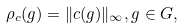Convert formula to latex. <formula><loc_0><loc_0><loc_500><loc_500>\rho _ { c } ( g ) = \| c ( g ) \| _ { \infty } , g \in G ,</formula> 